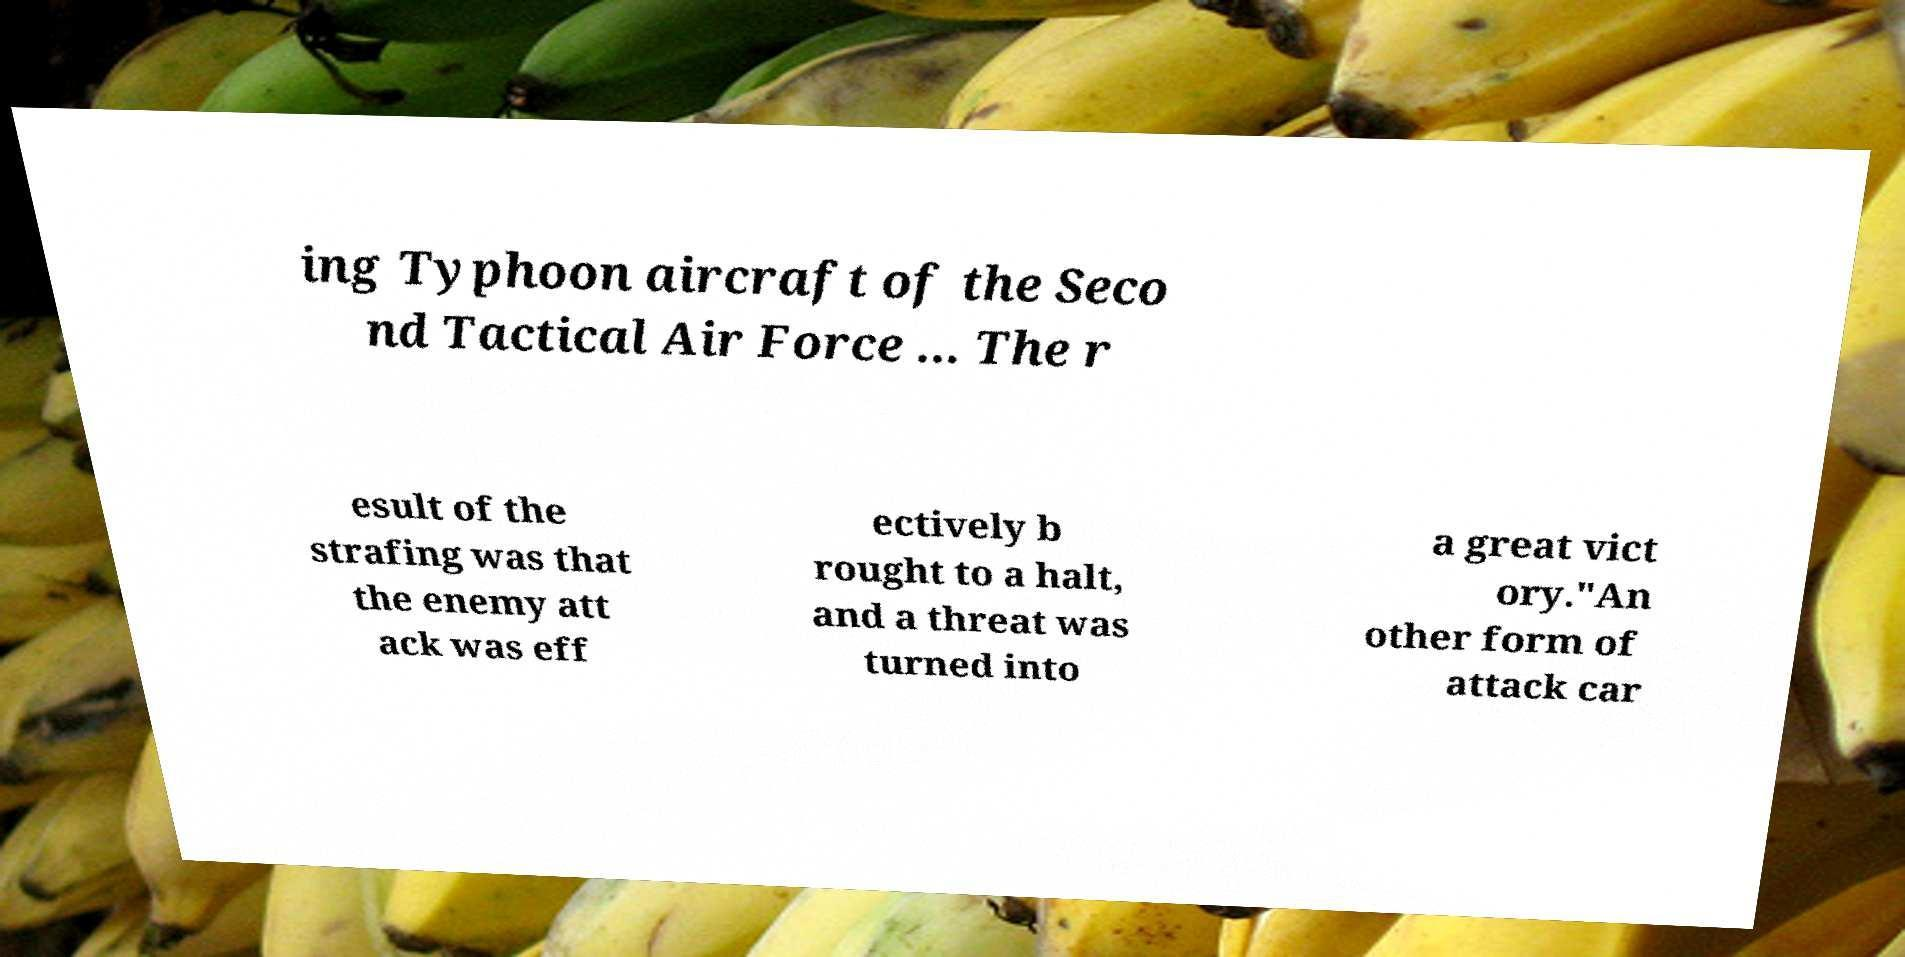Could you extract and type out the text from this image? ing Typhoon aircraft of the Seco nd Tactical Air Force ... The r esult of the strafing was that the enemy att ack was eff ectively b rought to a halt, and a threat was turned into a great vict ory."An other form of attack car 